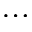Convert formula to latex. <formula><loc_0><loc_0><loc_500><loc_500>\dots</formula> 